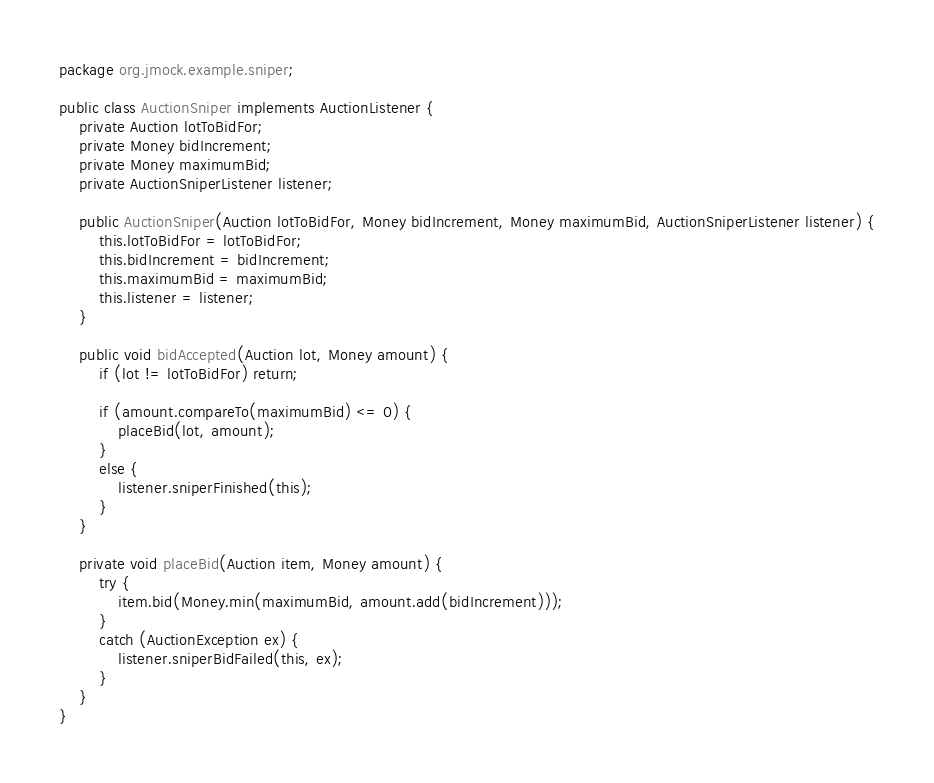<code> <loc_0><loc_0><loc_500><loc_500><_Java_>package org.jmock.example.sniper;

public class AuctionSniper implements AuctionListener {
    private Auction lotToBidFor;
    private Money bidIncrement;
    private Money maximumBid;
    private AuctionSniperListener listener;

    public AuctionSniper(Auction lotToBidFor, Money bidIncrement, Money maximumBid, AuctionSniperListener listener) {
        this.lotToBidFor = lotToBidFor;
        this.bidIncrement = bidIncrement;
        this.maximumBid = maximumBid;
        this.listener = listener;
    }

    public void bidAccepted(Auction lot, Money amount) {
        if (lot != lotToBidFor) return;

        if (amount.compareTo(maximumBid) <= 0) {
            placeBid(lot, amount);
        }
        else {
            listener.sniperFinished(this);
        }
    }

    private void placeBid(Auction item, Money amount) {
        try {
            item.bid(Money.min(maximumBid, amount.add(bidIncrement)));
        }
        catch (AuctionException ex) {
            listener.sniperBidFailed(this, ex);
        }
    }
}
</code> 